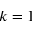<formula> <loc_0><loc_0><loc_500><loc_500>k = 1</formula> 